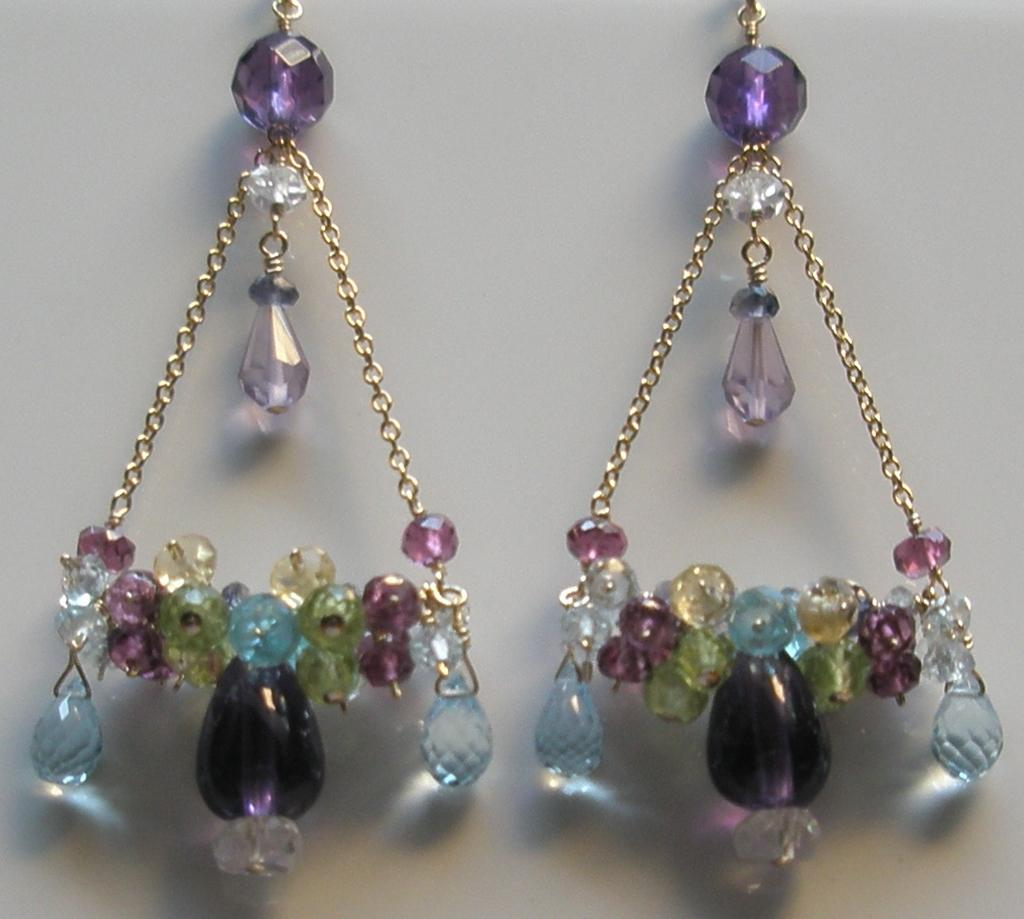What type of decorative items are present in the image? There are hangings with colorful beads and chains in the image. How are these hangings similar to a piece of jewelry? The hangings resemble earrings. Is there a gun visible in the image? No, there is no gun present in the image. 